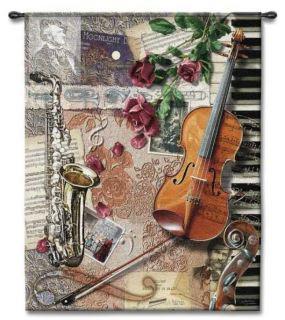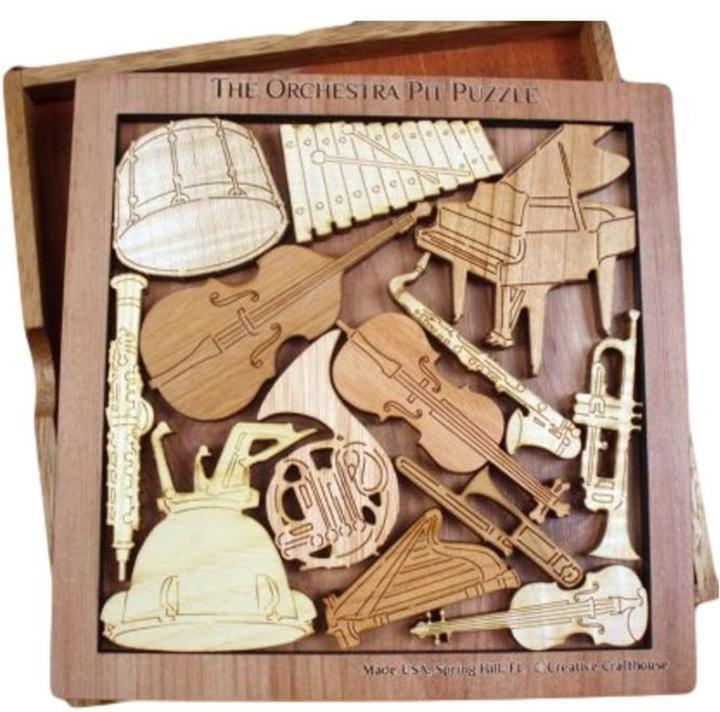The first image is the image on the left, the second image is the image on the right. Given the left and right images, does the statement "One image shows four art renderings of musical instruments, including saxophone, violin and keyboard, and the other image depicts a person standing and playing a saxophone." hold true? Answer yes or no. No. The first image is the image on the left, the second image is the image on the right. Assess this claim about the two images: "One of the drawings depicts a dog.". Correct or not? Answer yes or no. No. 